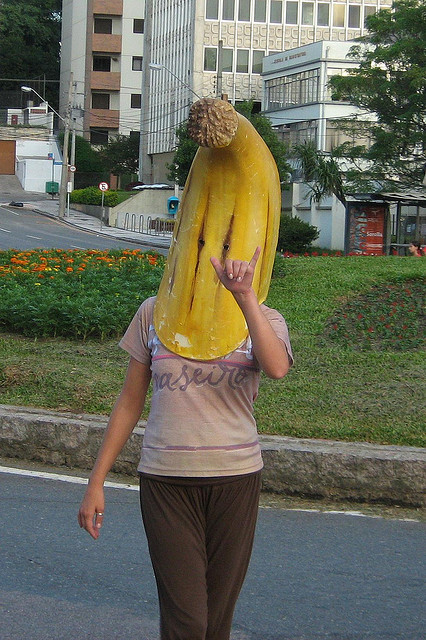Read all the text in this image. asiro 5 